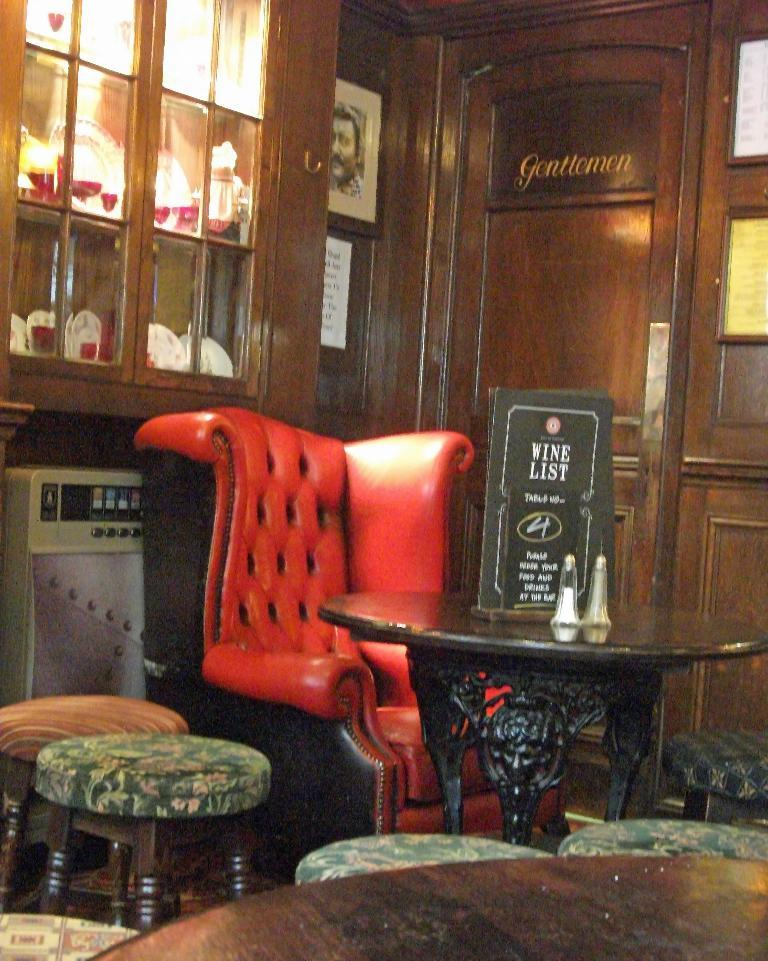What can be seen hanging on the wall in the image? There are frames on the wall in the image. What type of seating is present in the image? There are stools and a chair in the image. What is on the table in the image? There are objects on the table in the image. Where can additional objects be found in the image? There are objects in a cupboard on the left side of the image. How many children are playing with the scarecrow in the image? There are no children or scarecrow present in the image. What is the end result of the objects in the cupboard on the left side of the image? The provided facts do not mention an end result or purpose for the objects in the cupboard; they only mention their presence. 